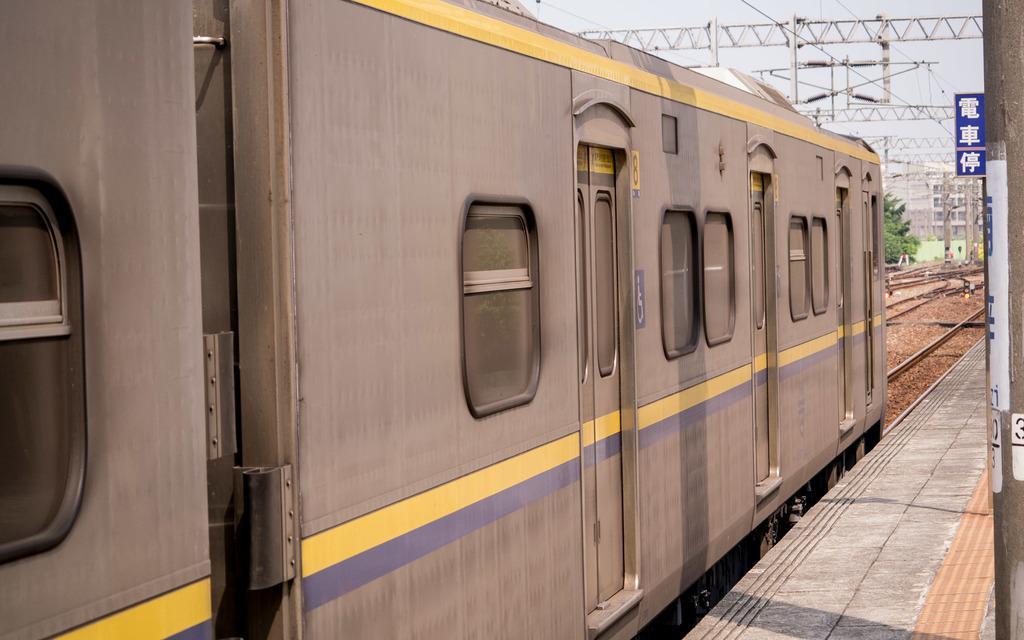Please provide a concise description of this image. In this image there is a train on the railway track. On the right side there is a platform on which there are poles. At the top there are metal stands to which there are wires. In the background there is a tree. 